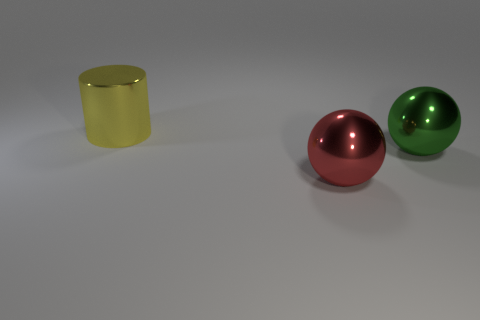What shape is the big yellow object that is the same material as the red sphere?
Keep it short and to the point. Cylinder. How many tiny blue cylinders are there?
Keep it short and to the point. 0. How many objects are either objects that are left of the red metallic sphere or large yellow metallic things?
Your answer should be very brief. 1. What number of other objects are the same color as the big cylinder?
Ensure brevity in your answer.  0. How many small things are green objects or shiny balls?
Keep it short and to the point. 0. Are there more big red balls than tiny yellow cubes?
Ensure brevity in your answer.  Yes. Are the large yellow cylinder and the large green sphere made of the same material?
Offer a very short reply. Yes. Is the number of big cylinders that are behind the big green metal object greater than the number of tiny purple matte cylinders?
Your response must be concise. Yes. What number of other big shiny objects have the same shape as the large yellow shiny thing?
Make the answer very short. 0. There is a large shiny object that is both to the right of the yellow cylinder and to the left of the large green metal ball; what color is it?
Provide a succinct answer. Red. 